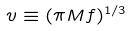<formula> <loc_0><loc_0><loc_500><loc_500>v \equiv ( \pi M f ) ^ { 1 / 3 }</formula> 